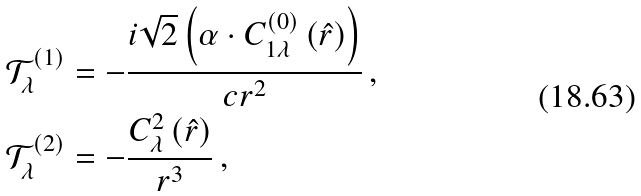<formula> <loc_0><loc_0><loc_500><loc_500>\mathcal { T } _ { \lambda } ^ { \left ( 1 \right ) } & = - \frac { i \sqrt { 2 } \left ( \alpha \cdot C _ { 1 \lambda } ^ { \left ( 0 \right ) } \left ( \hat { r } \right ) \right ) } { c r ^ { 2 } } \, , \\ \mathcal { T } _ { \lambda } ^ { \left ( 2 \right ) } & = - \frac { C _ { \lambda } ^ { 2 } \left ( \hat { r } \right ) } { r ^ { 3 } } \, ,</formula> 